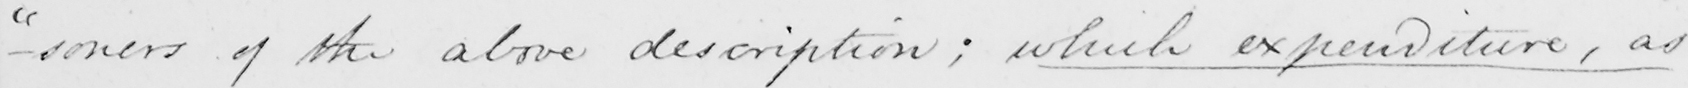What is written in this line of handwriting? -soners  " of the above description ; which expenditure , as 